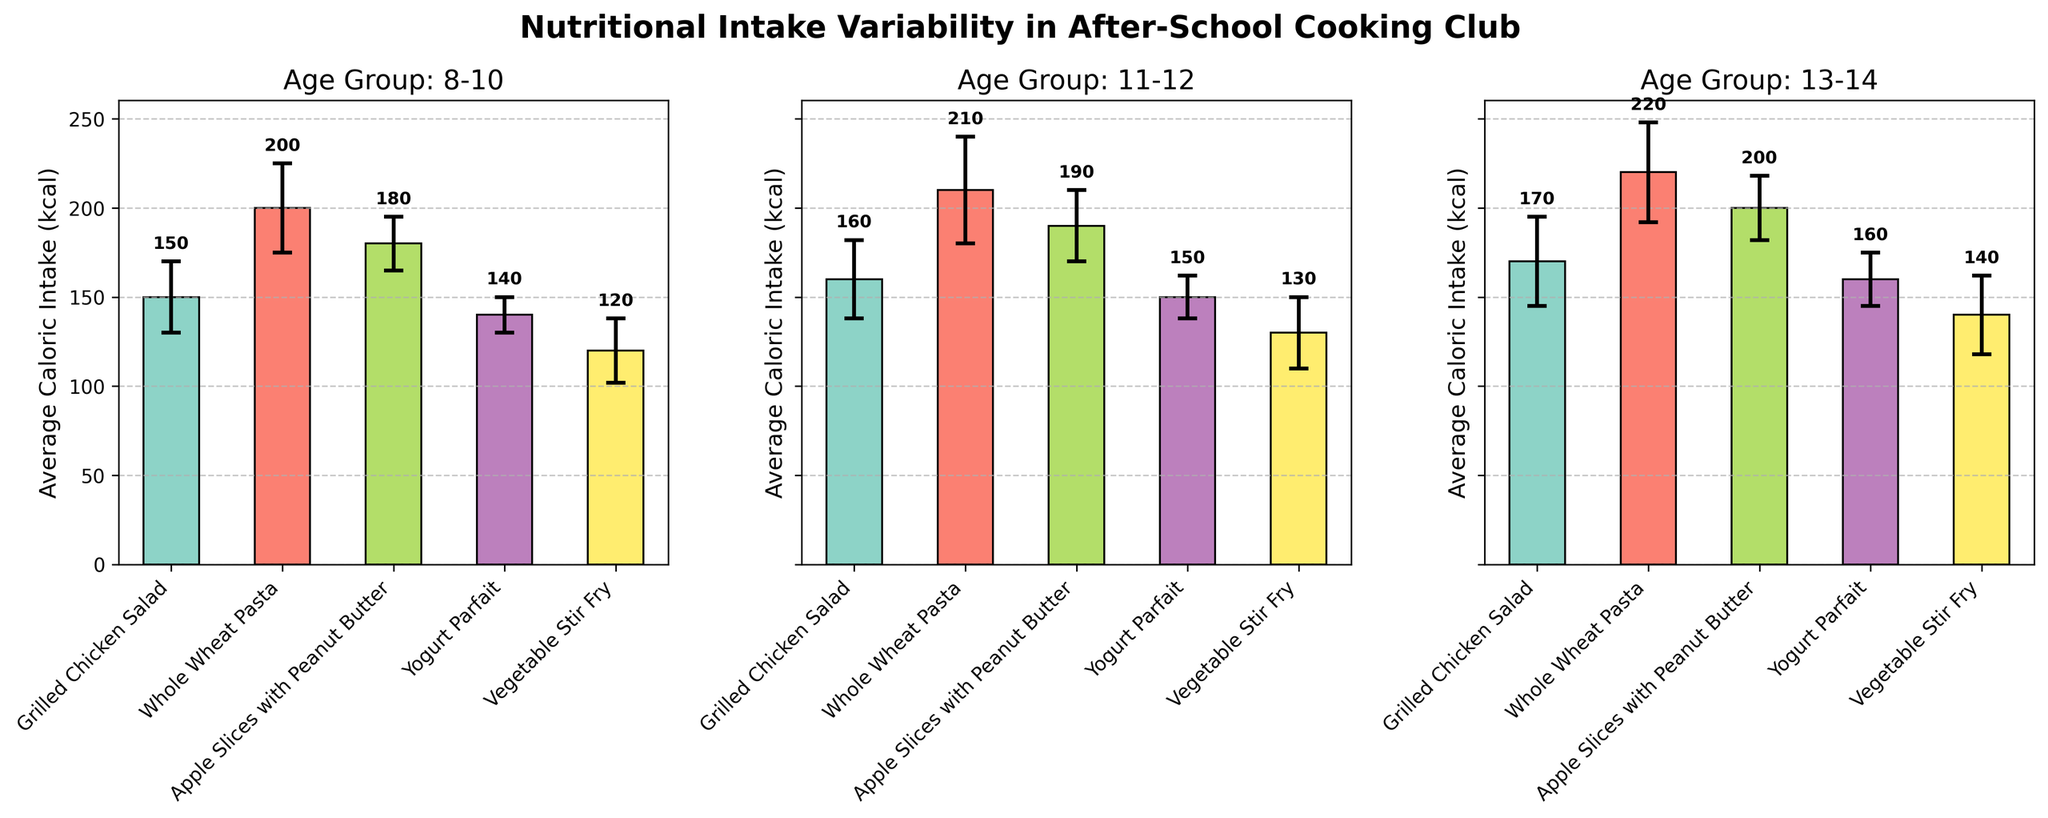What's the title of the figure? The title of the figure is located at the top and is clearly visible as "Nutritional Intake Variability in After-School Cooking Club."
Answer: Nutritional Intake Variability in After-School Cooking Club What is the average caloric intake for Whole Wheat Pasta in the 11-12 age group? Look at the subplot for the 11-12 age group and find Whole Wheat Pasta. The figure shows a bar for Whole Wheat Pasta with a label indicating the value.
Answer: 210 kcal Which food item has the lowest average caloric intake for the 8-10 age group? In the subplot for the 8-10 age group, compare the heights of the bars for each food item. The lowest bar corresponds to the item with the lowest average caloric intake.
Answer: Vegetable Stir Fry What is the standard deviation of caloric intake for Grilled Chicken Salad in the 13-14 age group? In the subplot for the 13-14 age group, find Grilled Chicken Salad and observe the error bar (caps) spanning from the top of the bar. The error bar's length represents the standard deviation.
Answer: 25 kcal Compare the average caloric intake of Yogurt Parfait in the 8-10 and 13-14 age groups. Which group has a higher intake? Look at the bars for Yogurt Parfait in both the 8-10 and 13-14 age group subplots. Compare their heights to determine which one is higher.
Answer: 13-14 age group Which age group shows the highest variability in caloric intake for Apple Slices with Peanut Butter? Compare the lengths of the error bars (caps) for Apple Slices with Peanut Butter across the three age groups. The longest error bar indicates the highest variability.
Answer: 11-12 age group How much more is the average caloric intake of Whole Wheat Pasta compared to Vegetable Stir Fry for the 13-14 age group? Find the average caloric intakes for Whole Wheat Pasta and Vegetable Stir Fry in the 13-14 age group and subtract the smaller value from the larger one. Whole Wheat Pasta (220 kcal) - Vegetable Stir Fry (140 kcal).
Answer: 80 kcal Which food item shows the smallest variation in caloric intake within the 8-10 age group? Look at the lengths of the error bars for each food item in the 8-10 age group plot. The smallest error bar indicates the smallest variation.
Answer: Yogurt Parfait 